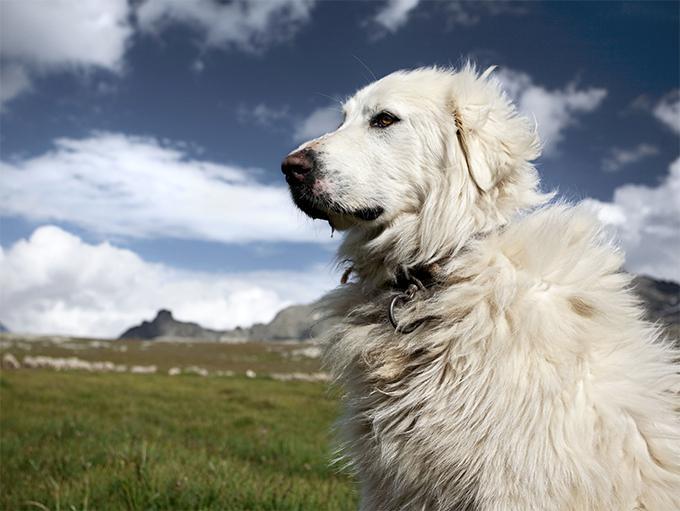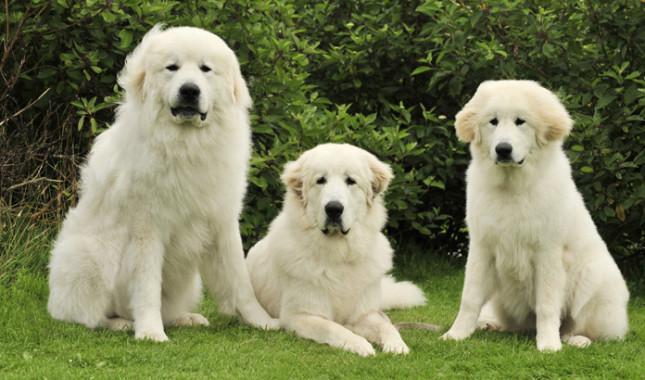The first image is the image on the left, the second image is the image on the right. Examine the images to the left and right. Is the description "A single dog is posing in a grassy area in the image on the left." accurate? Answer yes or no. Yes. The first image is the image on the left, the second image is the image on the right. Given the left and right images, does the statement "An image shows a white dog with body turned leftward, standing on all fours on a hard floor." hold true? Answer yes or no. No. 